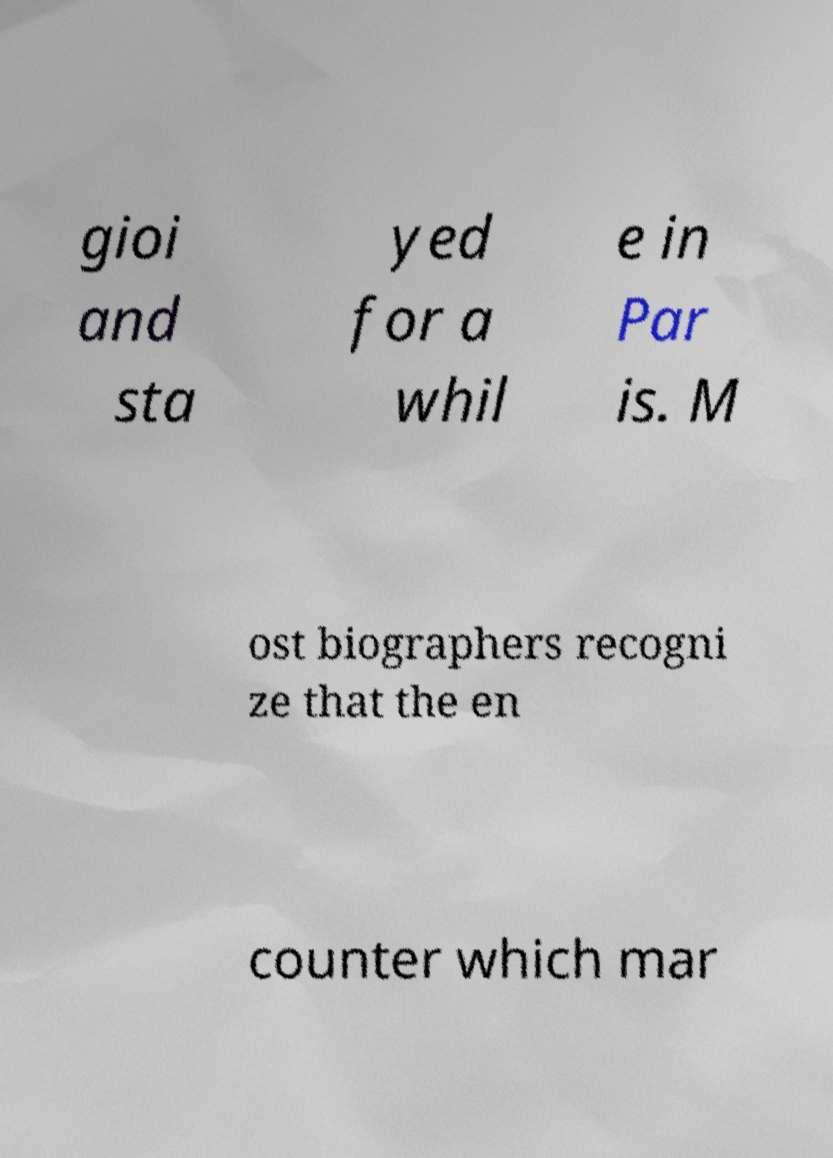Can you accurately transcribe the text from the provided image for me? gioi and sta yed for a whil e in Par is. M ost biographers recogni ze that the en counter which mar 